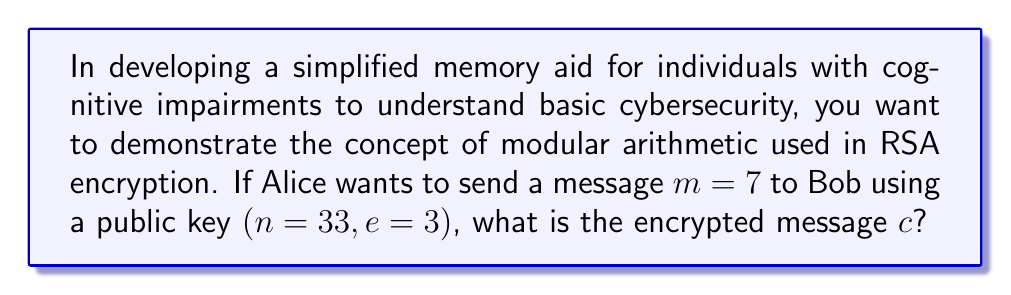Show me your answer to this math problem. To encrypt the message using RSA, we follow these steps:

1. We have the message $m = 7$ and the public key $(n = 33, e = 3)$.

2. The encryption formula in RSA is:
   $$c \equiv m^e \pmod{n}$$

3. Substituting the values:
   $$c \equiv 7^3 \pmod{33}$$

4. Calculate $7^3$:
   $$7^3 = 7 \times 7 \times 7 = 343$$

5. Now we need to find the remainder when 343 is divided by 33:
   $$343 \div 33 = 10 \text{ remainder } 13$$

6. Therefore:
   $$c \equiv 343 \equiv 13 \pmod{33}$$

The encrypted message is 13.
Answer: $13$ 